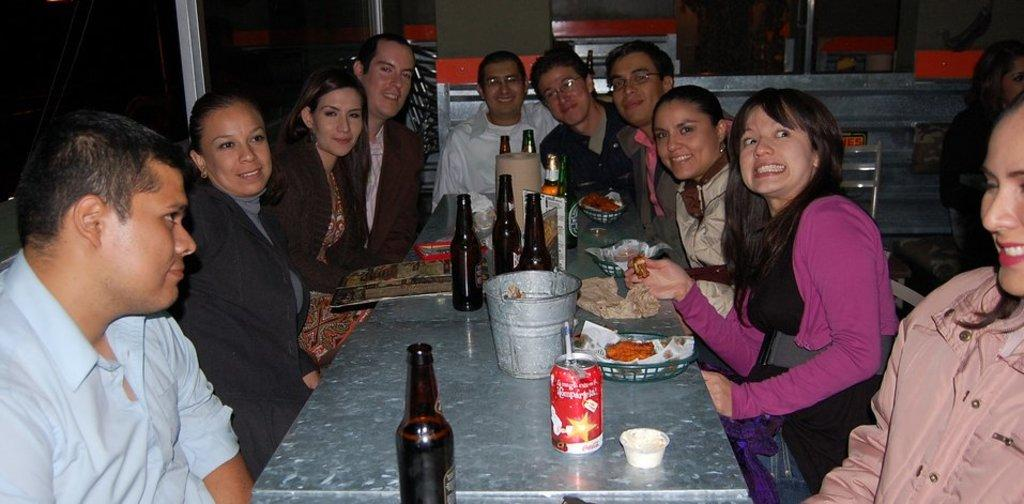What are the people in the image doing? The people in the image are sitting on chairs. What is present on the table in the image? There is a wine bottle, a bucket, and a juice can on the table. Can you describe the table in the image? There is a table in the image, and it has various items on it. What type of committee is meeting at the station in the image? There is no committee or station present in the image; it features people sitting on chairs and a table with various items. 